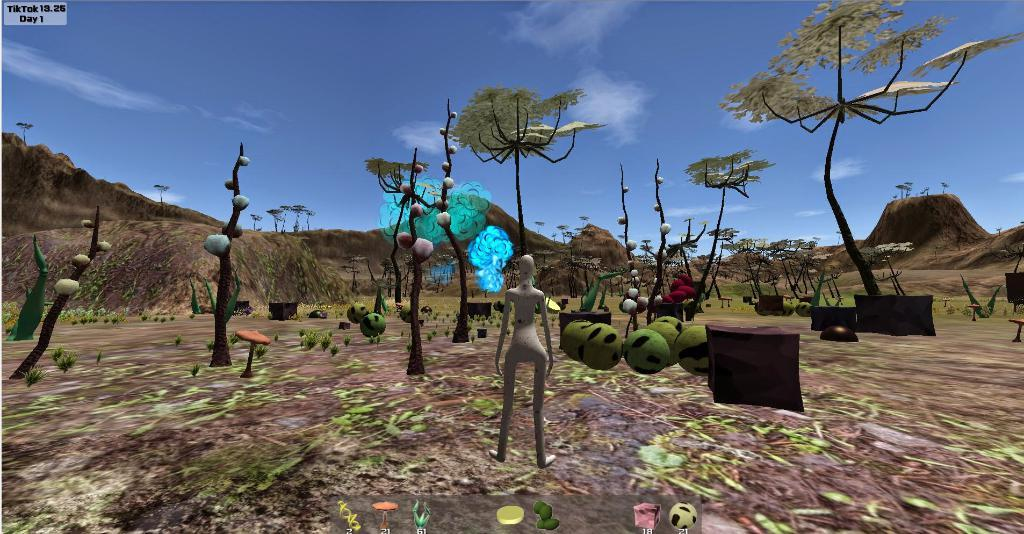What type of natural elements can be seen in the image? There are trees and hills visible in the image. What objects can be found on the land in the image? There are balls, plants, and a statue on the land in the image. What is the condition of the sky in the image? The sky is visible at the top of the image. What type of pump can be seen in harmony with the trees in the image? There is no pump present in the image, and the concept of harmony with the trees is not applicable. 